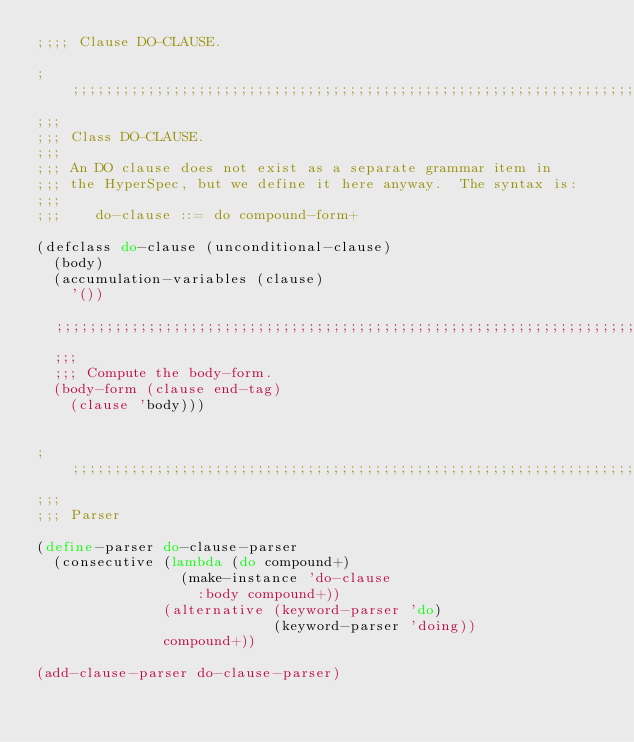<code> <loc_0><loc_0><loc_500><loc_500><_Scheme_>;;;; Clause DO-CLAUSE.

;;;;;;;;;;;;;;;;;;;;;;;;;;;;;;;;;;;;;;;;;;;;;;;;;;;;;;;;;;;;;;;;;;;;;;
;;;
;;; Class DO-CLAUSE.
;;;
;;; An DO clause does not exist as a separate grammar item in
;;; the HyperSpec, but we define it here anyway.  The syntax is:
;;;
;;;    do-clause ::= do compound-form+

(defclass do-clause (unconditional-clause)
  (body)
  (accumulation-variables (clause)
    '())

  ;;;;;;;;;;;;;;;;;;;;;;;;;;;;;;;;;;;;;;;;;;;;;;;;;;;;;;;;;;;;;;;;;;;;;;
  ;;;
  ;;; Compute the body-form.
  (body-form (clause end-tag)
    (clause 'body)))


;;;;;;;;;;;;;;;;;;;;;;;;;;;;;;;;;;;;;;;;;;;;;;;;;;;;;;;;;;;;;;;;;;;;;;
;;;
;;; Parser

(define-parser do-clause-parser
  (consecutive (lambda (do compound+)
                 (make-instance 'do-clause
                   :body compound+))
               (alternative (keyword-parser 'do)
                            (keyword-parser 'doing))
               compound+))

(add-clause-parser do-clause-parser)
</code> 